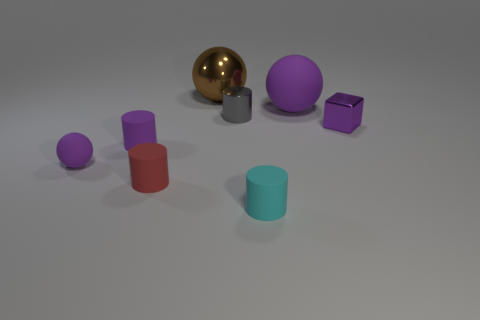There is a tiny purple rubber thing right of the purple ball that is left of the cyan rubber cylinder; what shape is it?
Your answer should be very brief. Cylinder. What size is the purple matte sphere in front of the purple thing behind the small purple thing on the right side of the big matte ball?
Make the answer very short. Small. The other shiny thing that is the same shape as the tiny red thing is what color?
Make the answer very short. Gray. Do the metallic cylinder and the cyan matte cylinder have the same size?
Your answer should be compact. Yes. There is a small object that is to the right of the small cyan rubber thing; what is it made of?
Your answer should be compact. Metal. How many other objects are the same shape as the purple shiny thing?
Keep it short and to the point. 0. Is the shape of the gray metallic object the same as the big matte object?
Make the answer very short. No. Are there any large shiny balls to the right of the gray metallic thing?
Provide a succinct answer. No. How many things are either brown matte balls or cylinders?
Provide a short and direct response. 4. How many other objects are the same size as the metal cube?
Ensure brevity in your answer.  5. 